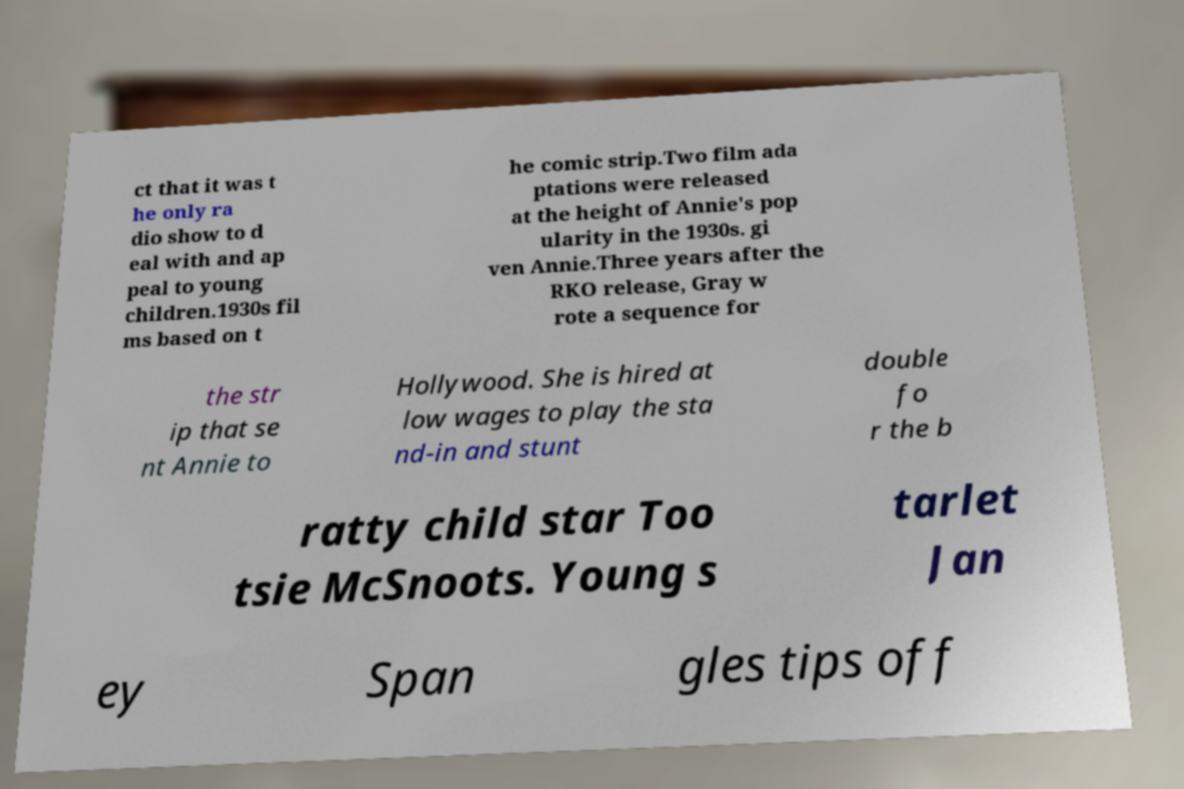Can you read and provide the text displayed in the image?This photo seems to have some interesting text. Can you extract and type it out for me? ct that it was t he only ra dio show to d eal with and ap peal to young children.1930s fil ms based on t he comic strip.Two film ada ptations were released at the height of Annie's pop ularity in the 1930s. gi ven Annie.Three years after the RKO release, Gray w rote a sequence for the str ip that se nt Annie to Hollywood. She is hired at low wages to play the sta nd-in and stunt double fo r the b ratty child star Too tsie McSnoots. Young s tarlet Jan ey Span gles tips off 